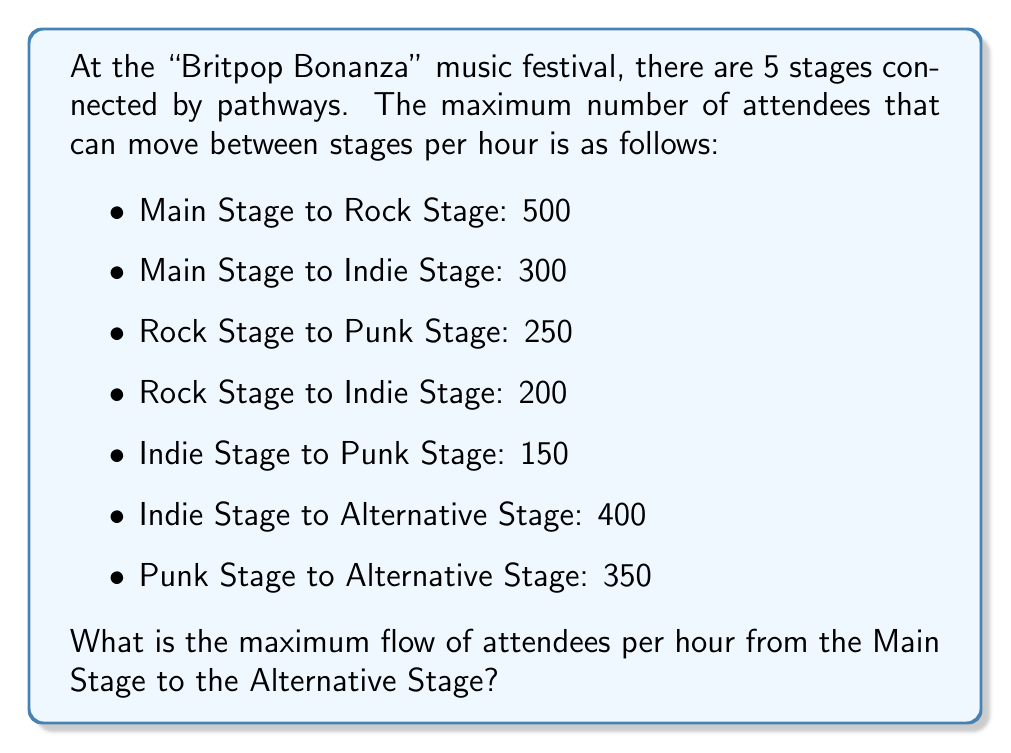Provide a solution to this math problem. To solve this problem, we'll use the Ford-Fulkerson algorithm to find the maximum flow in the network.

1) First, let's represent the festival layout as a directed graph:

[asy]
unitsize(1cm);

pair A = (0,0), B = (2,1), C = (2,-1), D = (4,1), E = (4,-1);

draw(A--B, arrow=Arrow());
draw(A--C, arrow=Arrow());
draw(B--C, arrow=Arrow());
draw(B--D, arrow=Arrow());
draw(C--D, arrow=Arrow());
draw(C--E, arrow=Arrow());
draw(D--E, arrow=Arrow());

label("Main", A, W);
label("Rock", B, N);
label("Indie", C, S);
label("Punk", D, N);
label("Alt", E, E);

label("500", (A--B), N);
label("300", (A--C), S);
label("200", (B--C), W);
label("250", (B--D), N);
label("150", (C--D), E);
label("400", (C--E), S);
label("350", (D--E), N);
[/asy]

2) We'll find augmenting paths from Main to Alternative until no more exist:

Path 1: Main -> Rock -> Punk -> Alternative
Flow: $\min(500, 250, 350) = 250$

Path 2: Main -> Indie -> Alternative
Flow: $\min(300, 400) = 300$

Path 3: Main -> Rock -> Indie -> Alternative
Flow: $\min(500-250, 200, 400-300) = 100$

3) No more augmenting paths exist. The maximum flow is the sum of the flows along these paths:

$250 + 300 + 100 = 650$

Therefore, the maximum flow of attendees per hour from the Main Stage to the Alternative Stage is 650.
Answer: 650 attendees per hour 